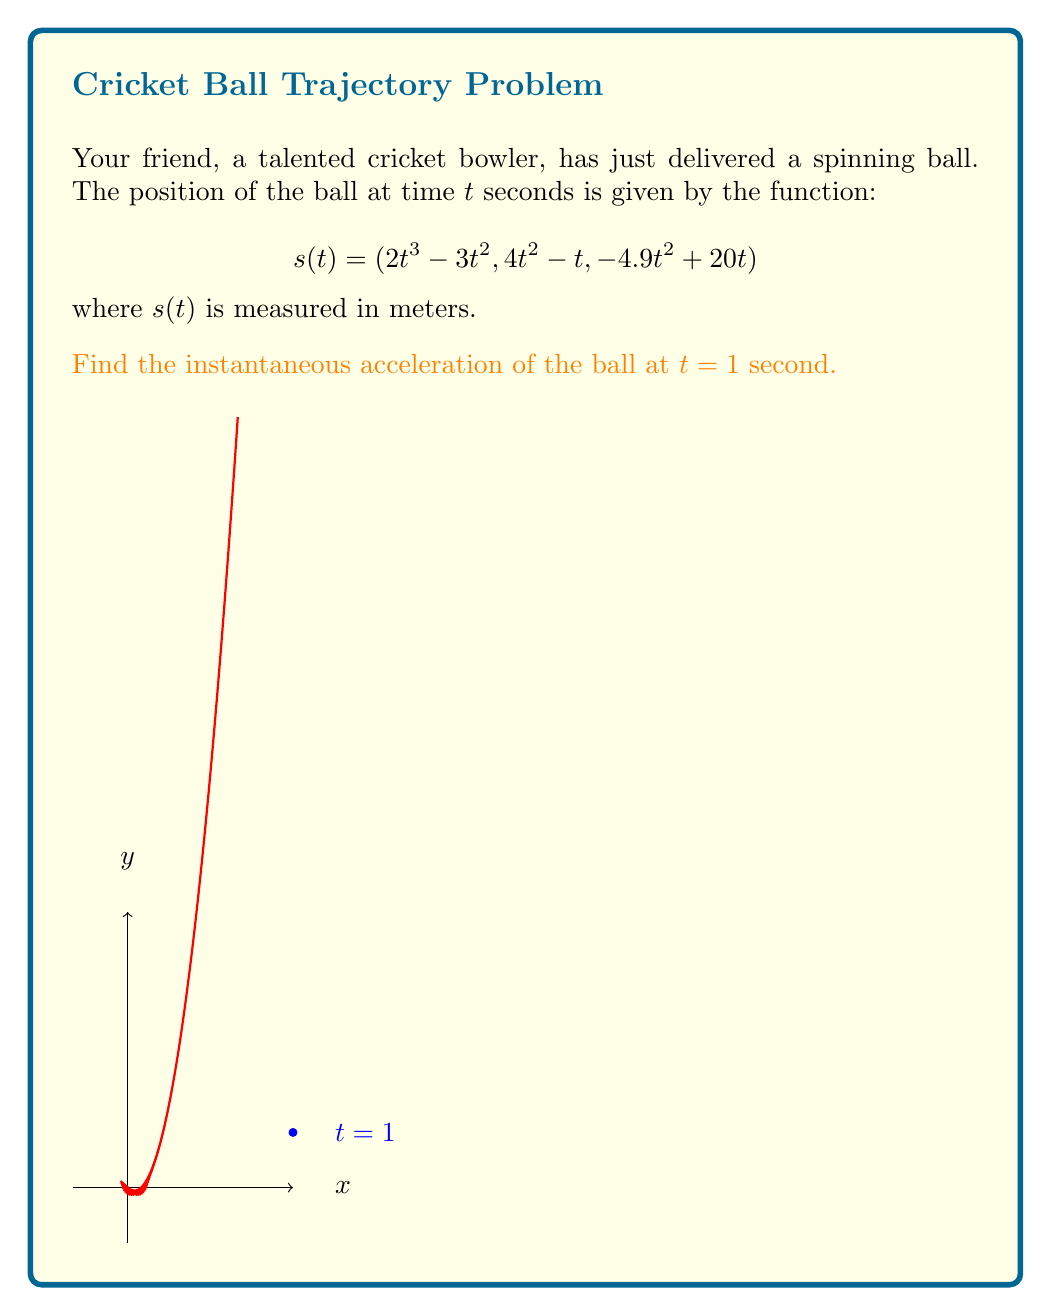Can you answer this question? To find the instantaneous acceleration, we need to differentiate the position function twice.

Step 1: Find the velocity function by differentiating $s(t)$:
$$v(t) = s'(t) = (6t^2 - 6t, 8t - 1, -9.8t + 20)$$

Step 2: Find the acceleration function by differentiating $v(t)$:
$$a(t) = v'(t) = (12t - 6, 8, -9.8)$$

Step 3: Evaluate $a(t)$ at $t = 1$:
$$a(1) = (12(1) - 6, 8, -9.8) = (6, 8, -9.8)$$

Step 4: Calculate the magnitude of the acceleration vector:
$$\|a(1)\| = \sqrt{6^2 + 8^2 + (-9.8)^2} = \sqrt{36 + 64 + 96.04} = \sqrt{196.04} \approx 14.001$$

Therefore, the instantaneous acceleration of the ball at $t = 1$ second is approximately 14.001 m/s².
Answer: $(6, 8, -9.8)$ m/s² or 14.001 m/s² 